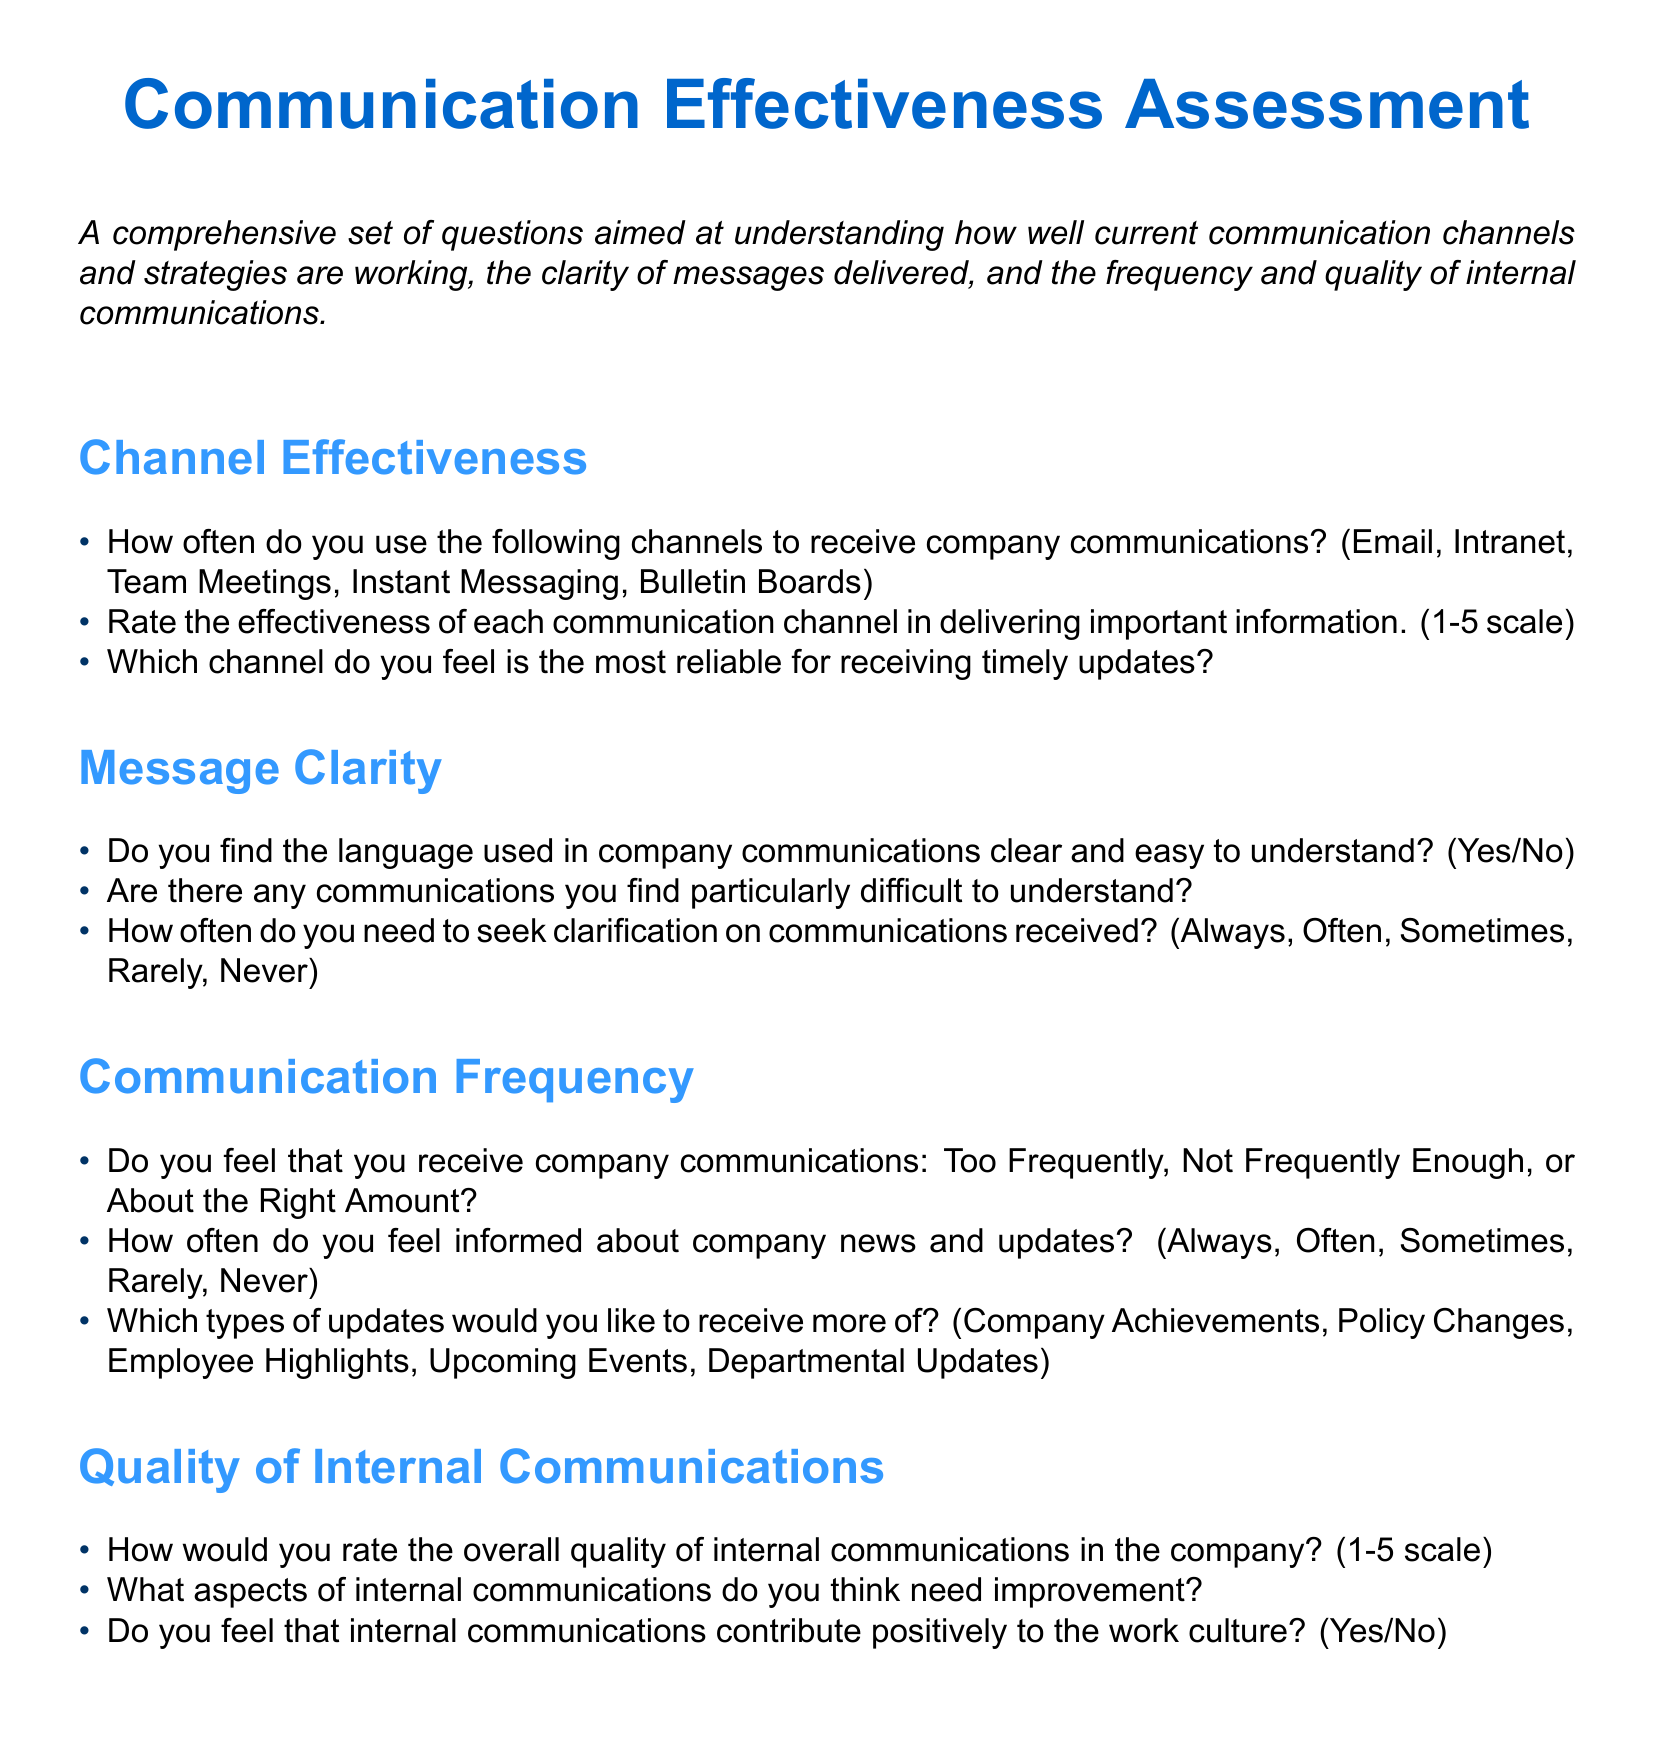What is the title of the document? The title is explicitly stated at the beginning of the document.
Answer: Communication Effectiveness Assessment How many sections are in the questionnaire? The document contains four main sections that address different communication aspects.
Answer: Four What scale is used to rate the effectiveness of communication channels? The document specifies a range for rating, which helps define the answer.
Answer: 1-5 scale Which communication channel is asked about for reliability? The question explicitly asks about the reliability of a single type of communication channel.
Answer: Most reliable What is one aspect of internal communications that respondents can suggest for improvement? The document prompts respondents to provide their thoughts on an aspect for improvement regarding internal communications.
Answer: Aspects needing improvement How do we quantify how often respondents seek clarification? The document provides frequency options that respondents can select.
Answer: Always, Often, Sometimes, Rarely, Never What is the total number of questions in the "Channel Effectiveness" section? The section lists specific inquiries that can be counted.
Answer: Three Do internal communications positively contribute to the work culture according to the questionnaire? The document includes a direct yes/no question regarding this aspect.
Answer: Yes/No What type of updates does the document ask about receiving more of? The questionnaire specifies the types of updates that can be requested.
Answer: Company Achievements, Policy Changes, Employee Highlights, Upcoming Events, Departmental Updates 